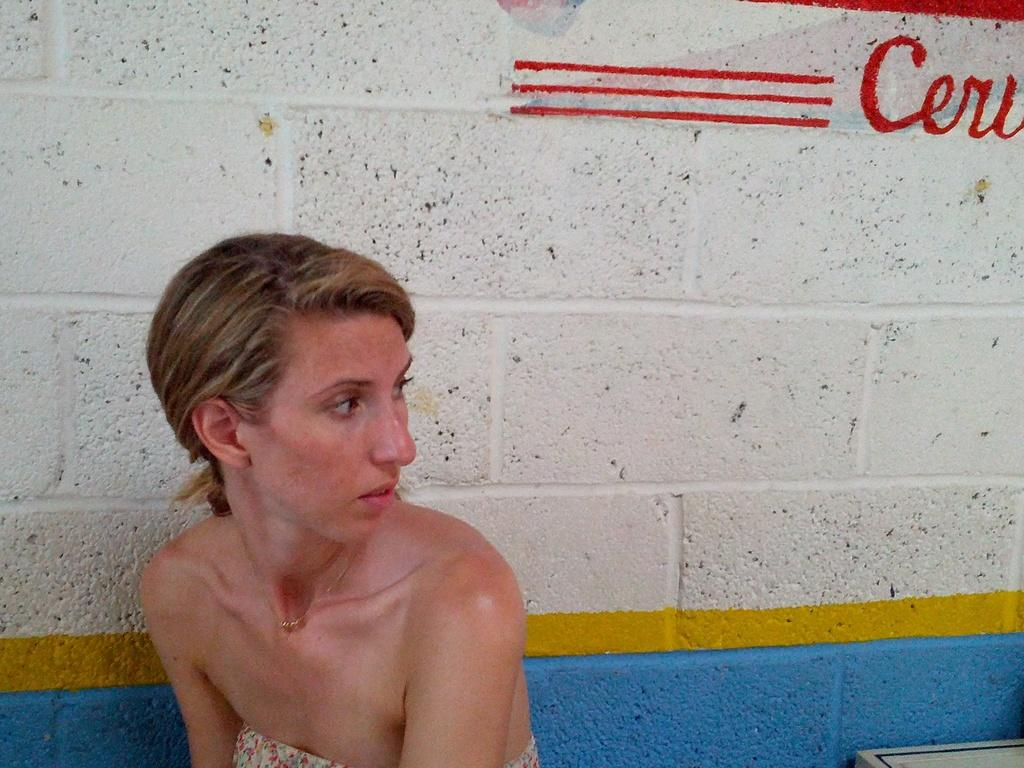Who is present in the image? There is a lady in the image. What can be seen in the background of the image? There is a wall in the background of the image. What type of potato is being used to milk a nut in the image? There is no potato, milk, or nut present in the image. 